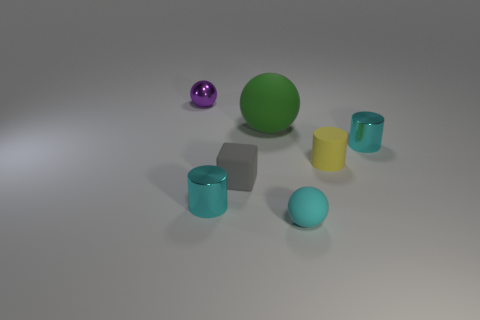Add 1 rubber things. How many objects exist? 8 Subtract all balls. How many objects are left? 4 Subtract all small cyan cylinders. Subtract all large green rubber spheres. How many objects are left? 4 Add 4 tiny metal cylinders. How many tiny metal cylinders are left? 6 Add 4 big spheres. How many big spheres exist? 5 Subtract 0 blue spheres. How many objects are left? 7 